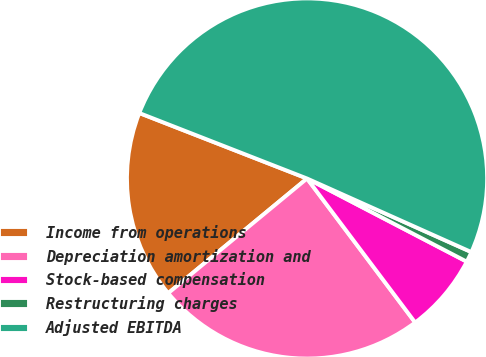Convert chart to OTSL. <chart><loc_0><loc_0><loc_500><loc_500><pie_chart><fcel>Income from operations<fcel>Depreciation amortization and<fcel>Stock-based compensation<fcel>Restructuring charges<fcel>Adjusted EBITDA<nl><fcel>16.91%<fcel>24.26%<fcel>7.11%<fcel>0.94%<fcel>50.77%<nl></chart> 